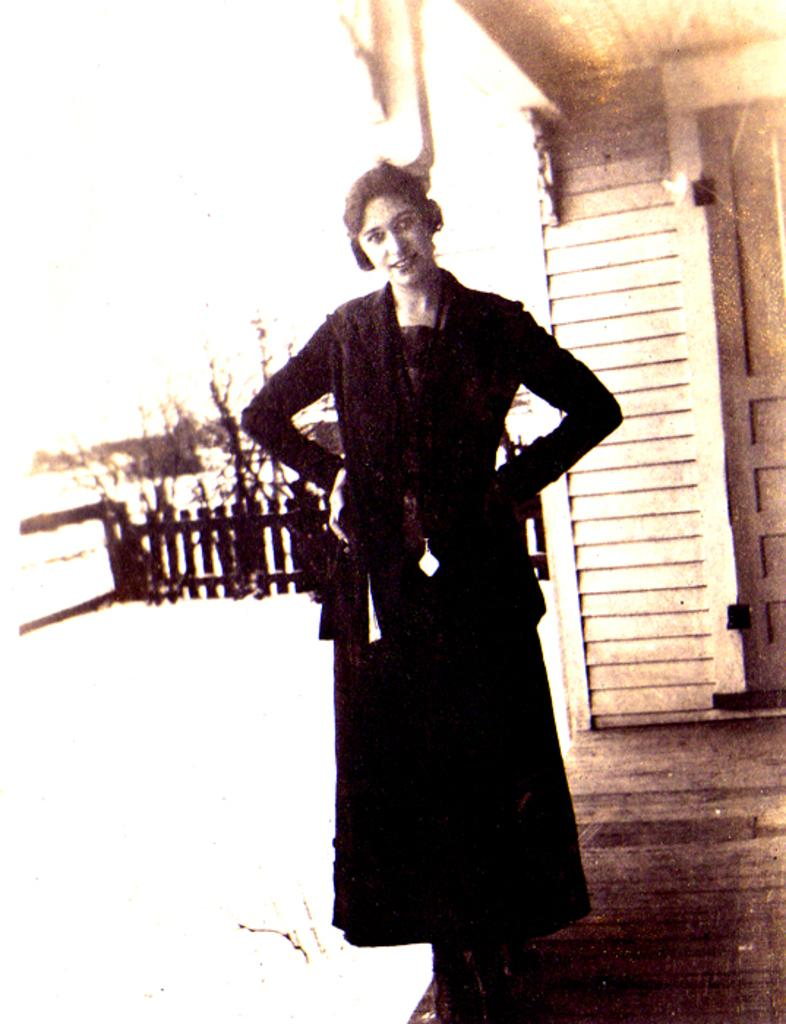What is the person in the image doing? There is no specific action mentioned, but we can see that the person is standing in the image. What is the person wearing? The person is wearing a black dress. What type of architectural feature can be seen in the image? There is a fencing visible in the image. What is the primary entrance in the image? There is a door in the image. What color is the background of the image? The background of the image is white. How many apples are being used to stir the spoon in the image? There are no apples or spoons present in the image. 